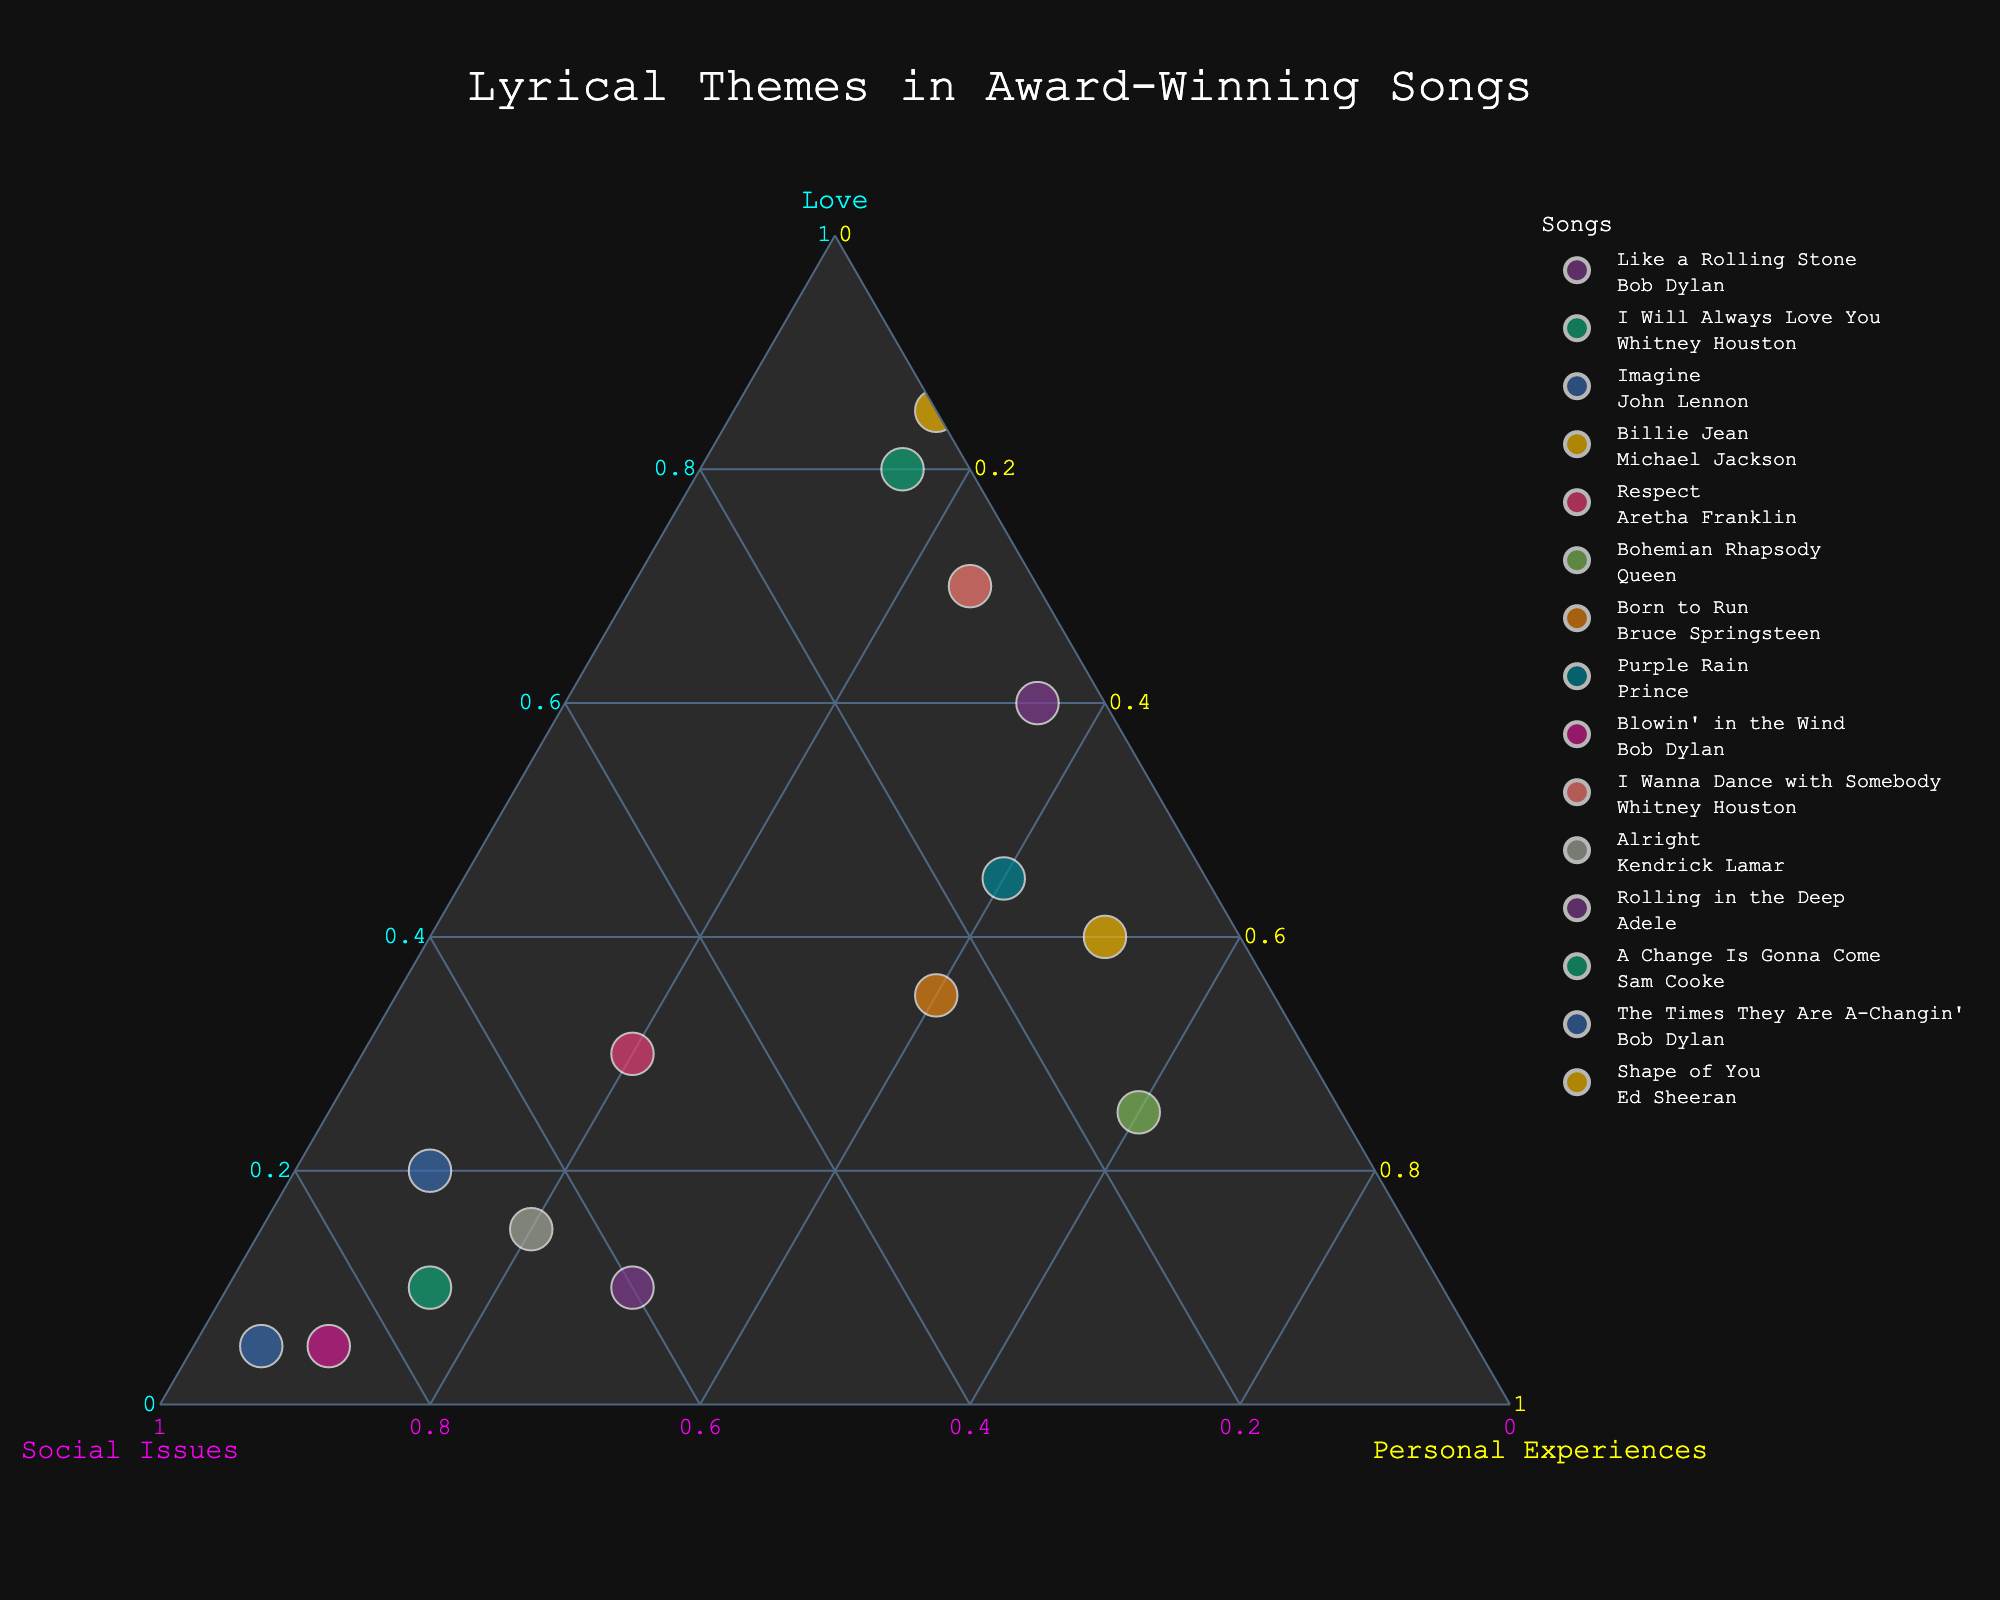What is the title of the figure? The title of the figure is usually displayed at the top of the plot. By glancing at this area, one can easily identify the title.
Answer: "Lyrical Themes in Award-Winning Songs" Which song has the highest representation of the 'Love' theme? Look for the data point that is closest to the 'Love' axis on the ternary plot. This indicates the highest representation of 'Love'.
Answer: "Shape of You" by Ed Sheeran How many songs have 'Social Issues' as their dominant theme? Count the number of data points closest to the 'Social Issues' axis. These represent the songs with 'Social Issues' as the dominant theme.
Answer: 3 What is the mid-point value on the 'Love' axis? Typically, the mid-point value of an axis in a ternary plot can be found halfway along the axis line. This value is 50%.
Answer: 50% Which song has the least representation of 'Personal Experiences'? Identify the data point that is furthest from the 'Personal Experiences' axis. This indicates the least representation of 'Personal Experiences'.
Answer: "The Times They Are A-Changin'" by Bob Dylan Compare the representation of 'Love' in "I Will Always Love You" and "Rolling in the Deep". Which one is higher and by how much? Look at the specific values for 'Love' in both songs and subtract the smaller value from the larger one. "I Will Always Love You" has 80% 'Love' and "Rolling in the Deep" has 60% 'Love'. The difference is 80% - 60% = 20%.
Answer: "I Will Always Love You" by 20% Identify a song that has an almost equal representation of 'Love' and 'Personal Experiences'. Look for a data point where the values for 'Love' and 'Personal Experiences' are nearly the same. "Rolling in the Deep" has 60% 'Love' and 35% 'Personal Experiences'. The values are not exactly equal, but they are close.
Answer: "Rolling in the Deep" by Adele Which song has the highest combined representation of 'Love' and 'Personal Experiences'? Add the percentages of 'Love' and 'Personal Experiences' for each song and identify the one with the highest total. "Shape of You" has 85% 'Love' + 15% 'Personal Experiences' = 100%.
Answer: "Shape of You" by Ed Sheeran Between "Respect" and "Blowin' in the Wind", which song has a higher representation of 'Social Issues' and what is the difference in their percentages? Check the values for 'Social Issues' for both songs. "Respect" has 50% and "Blowin' in the Wind" has 85%. The difference is 85% - 50% = 35%.
Answer: "Blowin' in the Wind" by 35% 